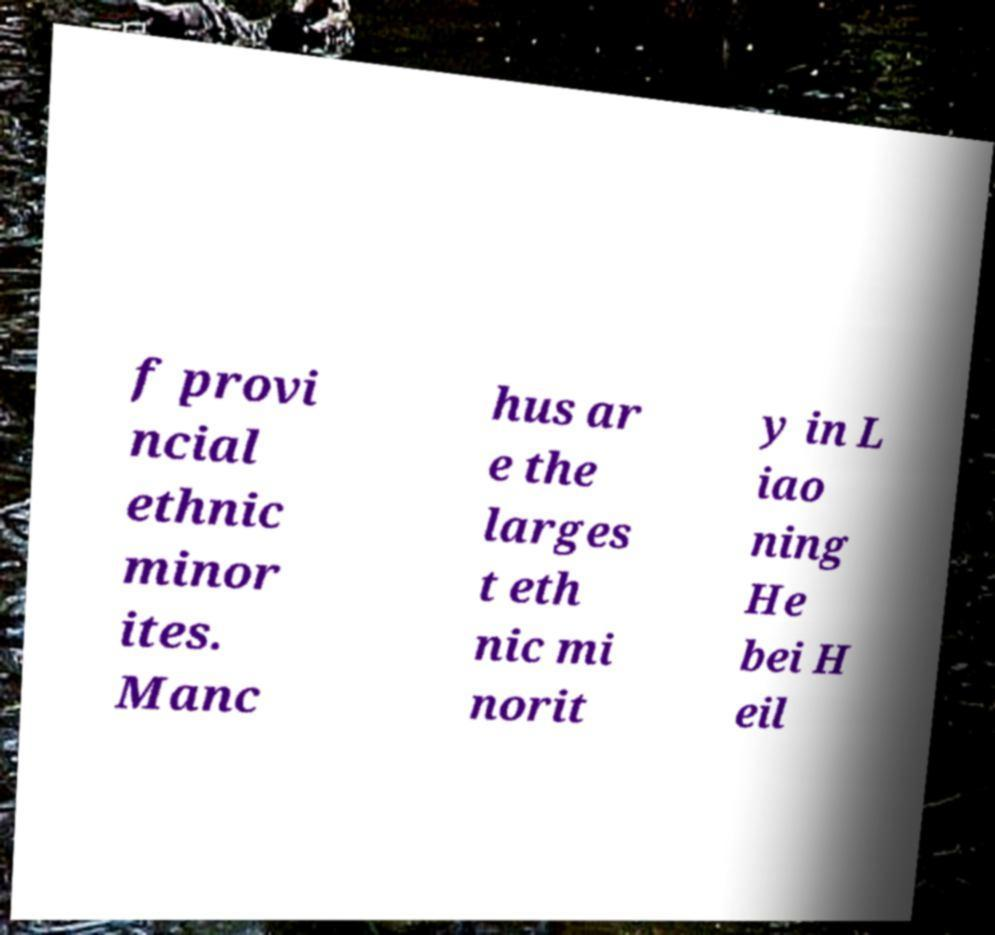Please read and relay the text visible in this image. What does it say? f provi ncial ethnic minor ites. Manc hus ar e the larges t eth nic mi norit y in L iao ning He bei H eil 